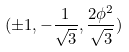Convert formula to latex. <formula><loc_0><loc_0><loc_500><loc_500>( \pm 1 , - \frac { 1 } { \sqrt { 3 } } , \frac { 2 \phi ^ { 2 } } { \sqrt { 3 } } )</formula> 